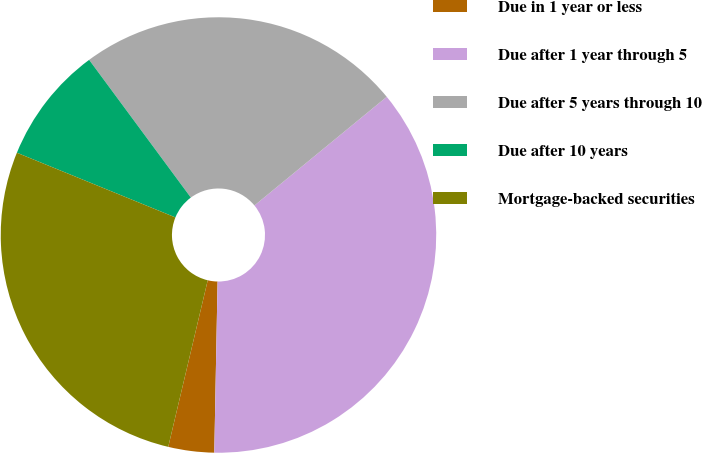Convert chart to OTSL. <chart><loc_0><loc_0><loc_500><loc_500><pie_chart><fcel>Due in 1 year or less<fcel>Due after 1 year through 5<fcel>Due after 5 years through 10<fcel>Due after 10 years<fcel>Mortgage-backed securities<nl><fcel>3.4%<fcel>36.25%<fcel>24.18%<fcel>8.71%<fcel>27.46%<nl></chart> 